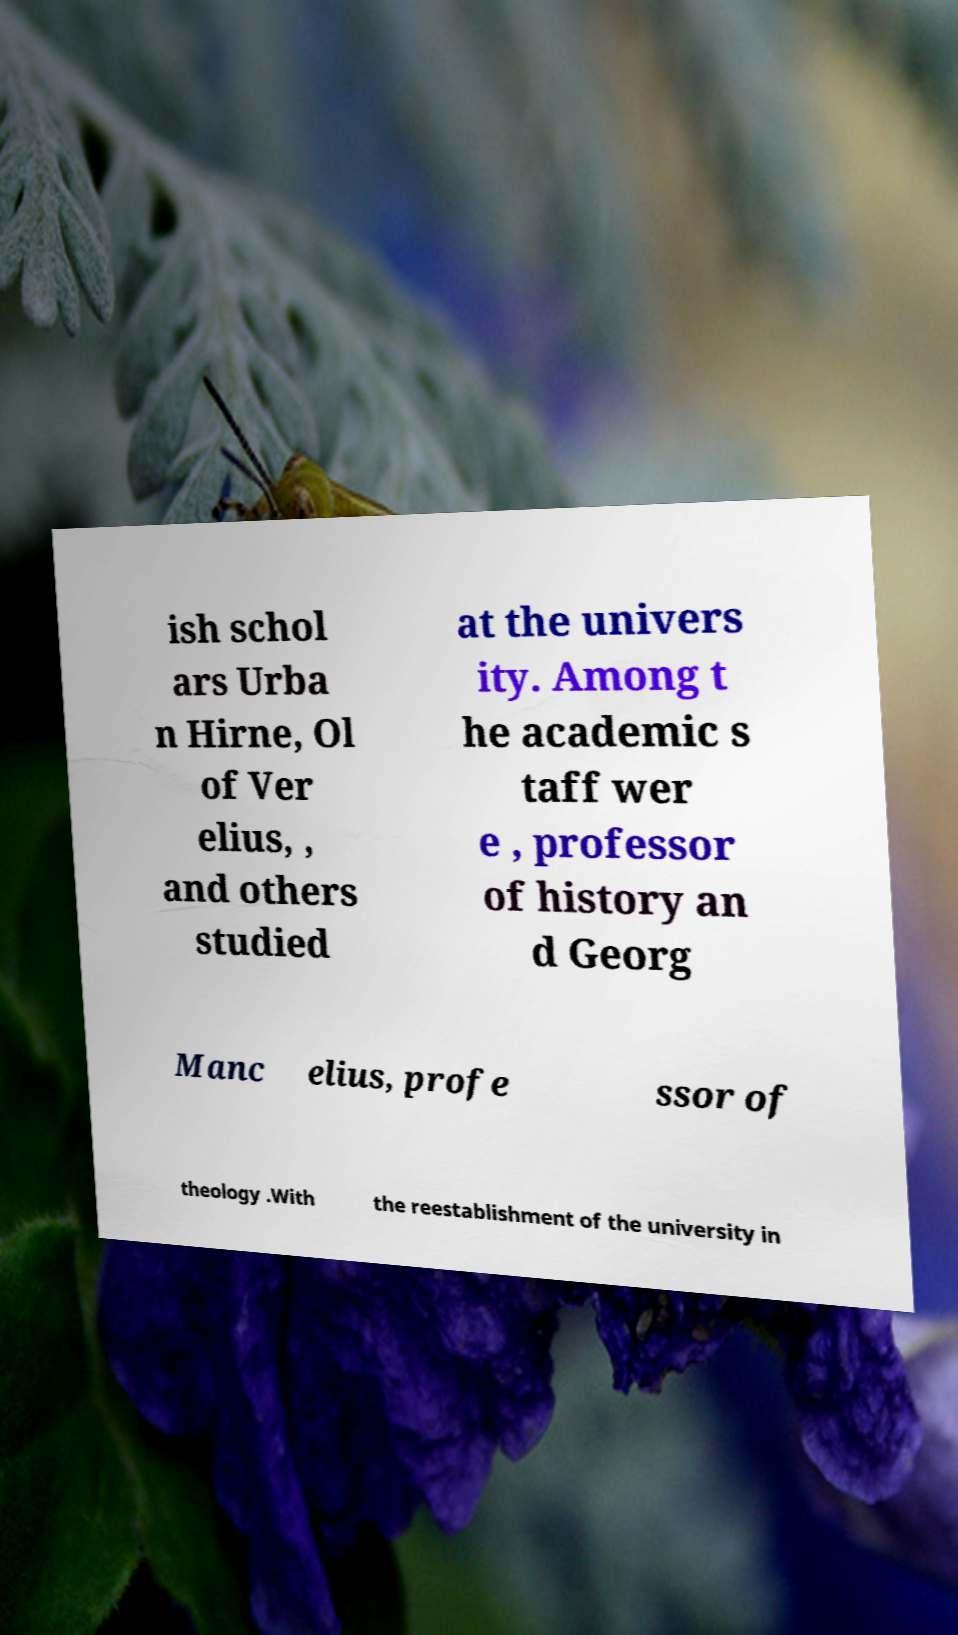Can you accurately transcribe the text from the provided image for me? ish schol ars Urba n Hirne, Ol of Ver elius, , and others studied at the univers ity. Among t he academic s taff wer e , professor of history an d Georg Manc elius, profe ssor of theology .With the reestablishment of the university in 